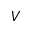<formula> <loc_0><loc_0><loc_500><loc_500>V</formula> 